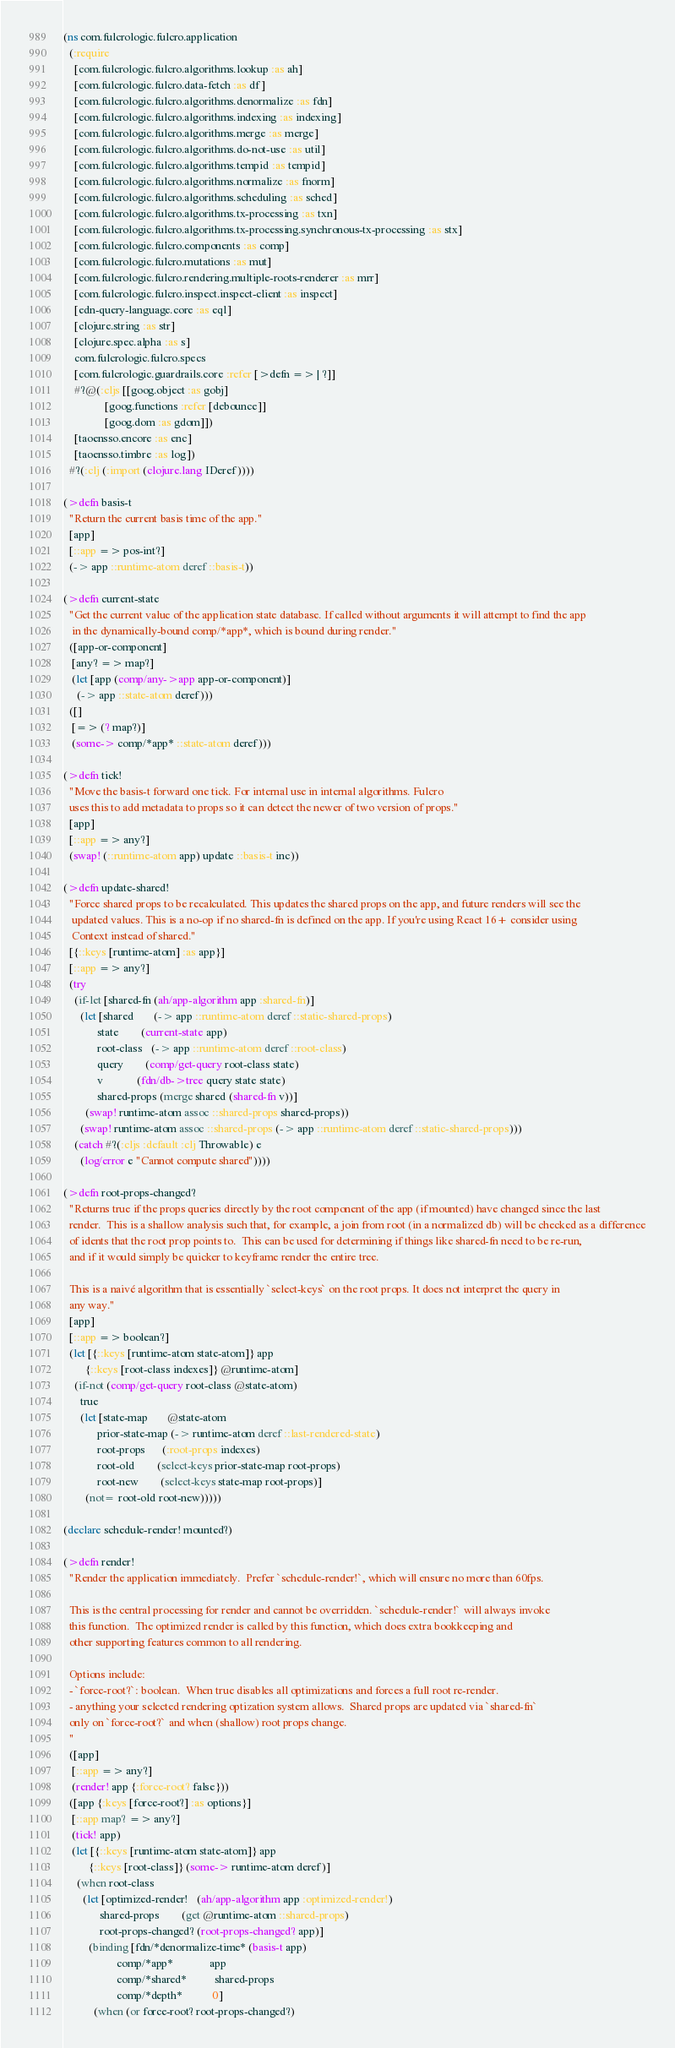<code> <loc_0><loc_0><loc_500><loc_500><_Clojure_>(ns com.fulcrologic.fulcro.application
  (:require
    [com.fulcrologic.fulcro.algorithms.lookup :as ah]
    [com.fulcrologic.fulcro.data-fetch :as df]
    [com.fulcrologic.fulcro.algorithms.denormalize :as fdn]
    [com.fulcrologic.fulcro.algorithms.indexing :as indexing]
    [com.fulcrologic.fulcro.algorithms.merge :as merge]
    [com.fulcrologic.fulcro.algorithms.do-not-use :as util]
    [com.fulcrologic.fulcro.algorithms.tempid :as tempid]
    [com.fulcrologic.fulcro.algorithms.normalize :as fnorm]
    [com.fulcrologic.fulcro.algorithms.scheduling :as sched]
    [com.fulcrologic.fulcro.algorithms.tx-processing :as txn]
    [com.fulcrologic.fulcro.algorithms.tx-processing.synchronous-tx-processing :as stx]
    [com.fulcrologic.fulcro.components :as comp]
    [com.fulcrologic.fulcro.mutations :as mut]
    [com.fulcrologic.fulcro.rendering.multiple-roots-renderer :as mrr]
    [com.fulcrologic.fulcro.inspect.inspect-client :as inspect]
    [edn-query-language.core :as eql]
    [clojure.string :as str]
    [clojure.spec.alpha :as s]
    com.fulcrologic.fulcro.specs
    [com.fulcrologic.guardrails.core :refer [>defn => | ?]]
    #?@(:cljs [[goog.object :as gobj]
               [goog.functions :refer [debounce]]
               [goog.dom :as gdom]])
    [taoensso.encore :as enc]
    [taoensso.timbre :as log])
  #?(:clj (:import (clojure.lang IDeref))))

(>defn basis-t
  "Return the current basis time of the app."
  [app]
  [::app => pos-int?]
  (-> app ::runtime-atom deref ::basis-t))

(>defn current-state
  "Get the current value of the application state database. If called without arguments it will attempt to find the app
   in the dynamically-bound comp/*app*, which is bound during render."
  ([app-or-component]
   [any? => map?]
   (let [app (comp/any->app app-or-component)]
     (-> app ::state-atom deref)))
  ([]
   [=> (? map?)]
   (some-> comp/*app* ::state-atom deref)))

(>defn tick!
  "Move the basis-t forward one tick. For internal use in internal algorithms. Fulcro
  uses this to add metadata to props so it can detect the newer of two version of props."
  [app]
  [::app => any?]
  (swap! (::runtime-atom app) update ::basis-t inc))

(>defn update-shared!
  "Force shared props to be recalculated. This updates the shared props on the app, and future renders will see the
   updated values. This is a no-op if no shared-fn is defined on the app. If you're using React 16+ consider using
   Context instead of shared."
  [{::keys [runtime-atom] :as app}]
  [::app => any?]
  (try
    (if-let [shared-fn (ah/app-algorithm app :shared-fn)]
      (let [shared       (-> app ::runtime-atom deref ::static-shared-props)
            state        (current-state app)
            root-class   (-> app ::runtime-atom deref ::root-class)
            query        (comp/get-query root-class state)
            v            (fdn/db->tree query state state)
            shared-props (merge shared (shared-fn v))]
        (swap! runtime-atom assoc ::shared-props shared-props))
      (swap! runtime-atom assoc ::shared-props (-> app ::runtime-atom deref ::static-shared-props)))
    (catch #?(:cljs :default :clj Throwable) e
      (log/error e "Cannot compute shared"))))

(>defn root-props-changed?
  "Returns true if the props queries directly by the root component of the app (if mounted) have changed since the last
  render.  This is a shallow analysis such that, for example, a join from root (in a normalized db) will be checked as a difference
  of idents that the root prop points to.  This can be used for determining if things like shared-fn need to be re-run,
  and if it would simply be quicker to keyframe render the entire tree.

  This is a naivé algorithm that is essentially `select-keys` on the root props. It does not interpret the query in
  any way."
  [app]
  [::app => boolean?]
  (let [{::keys [runtime-atom state-atom]} app
        {::keys [root-class indexes]} @runtime-atom]
    (if-not (comp/get-query root-class @state-atom)
      true
      (let [state-map       @state-atom
            prior-state-map (-> runtime-atom deref ::last-rendered-state)
            root-props      (:root-props indexes)
            root-old        (select-keys prior-state-map root-props)
            root-new        (select-keys state-map root-props)]
        (not= root-old root-new)))))

(declare schedule-render! mounted?)

(>defn render!
  "Render the application immediately.  Prefer `schedule-render!`, which will ensure no more than 60fps.

  This is the central processing for render and cannot be overridden. `schedule-render!` will always invoke
  this function.  The optimized render is called by this function, which does extra bookkeeping and
  other supporting features common to all rendering.

  Options include:
  - `force-root?`: boolean.  When true disables all optimizations and forces a full root re-render.
  - anything your selected rendering optization system allows.  Shared props are updated via `shared-fn`
  only on `force-root?` and when (shallow) root props change.
  "
  ([app]
   [::app => any?]
   (render! app {:force-root? false}))
  ([app {:keys [force-root?] :as options}]
   [::app map? => any?]
   (tick! app)
   (let [{::keys [runtime-atom state-atom]} app
         {::keys [root-class]} (some-> runtime-atom deref)]
     (when root-class
       (let [optimized-render!   (ah/app-algorithm app :optimized-render!)
             shared-props        (get @runtime-atom ::shared-props)
             root-props-changed? (root-props-changed? app)]
         (binding [fdn/*denormalize-time* (basis-t app)
                   comp/*app*             app
                   comp/*shared*          shared-props
                   comp/*depth*           0]
           (when (or force-root? root-props-changed?)</code> 